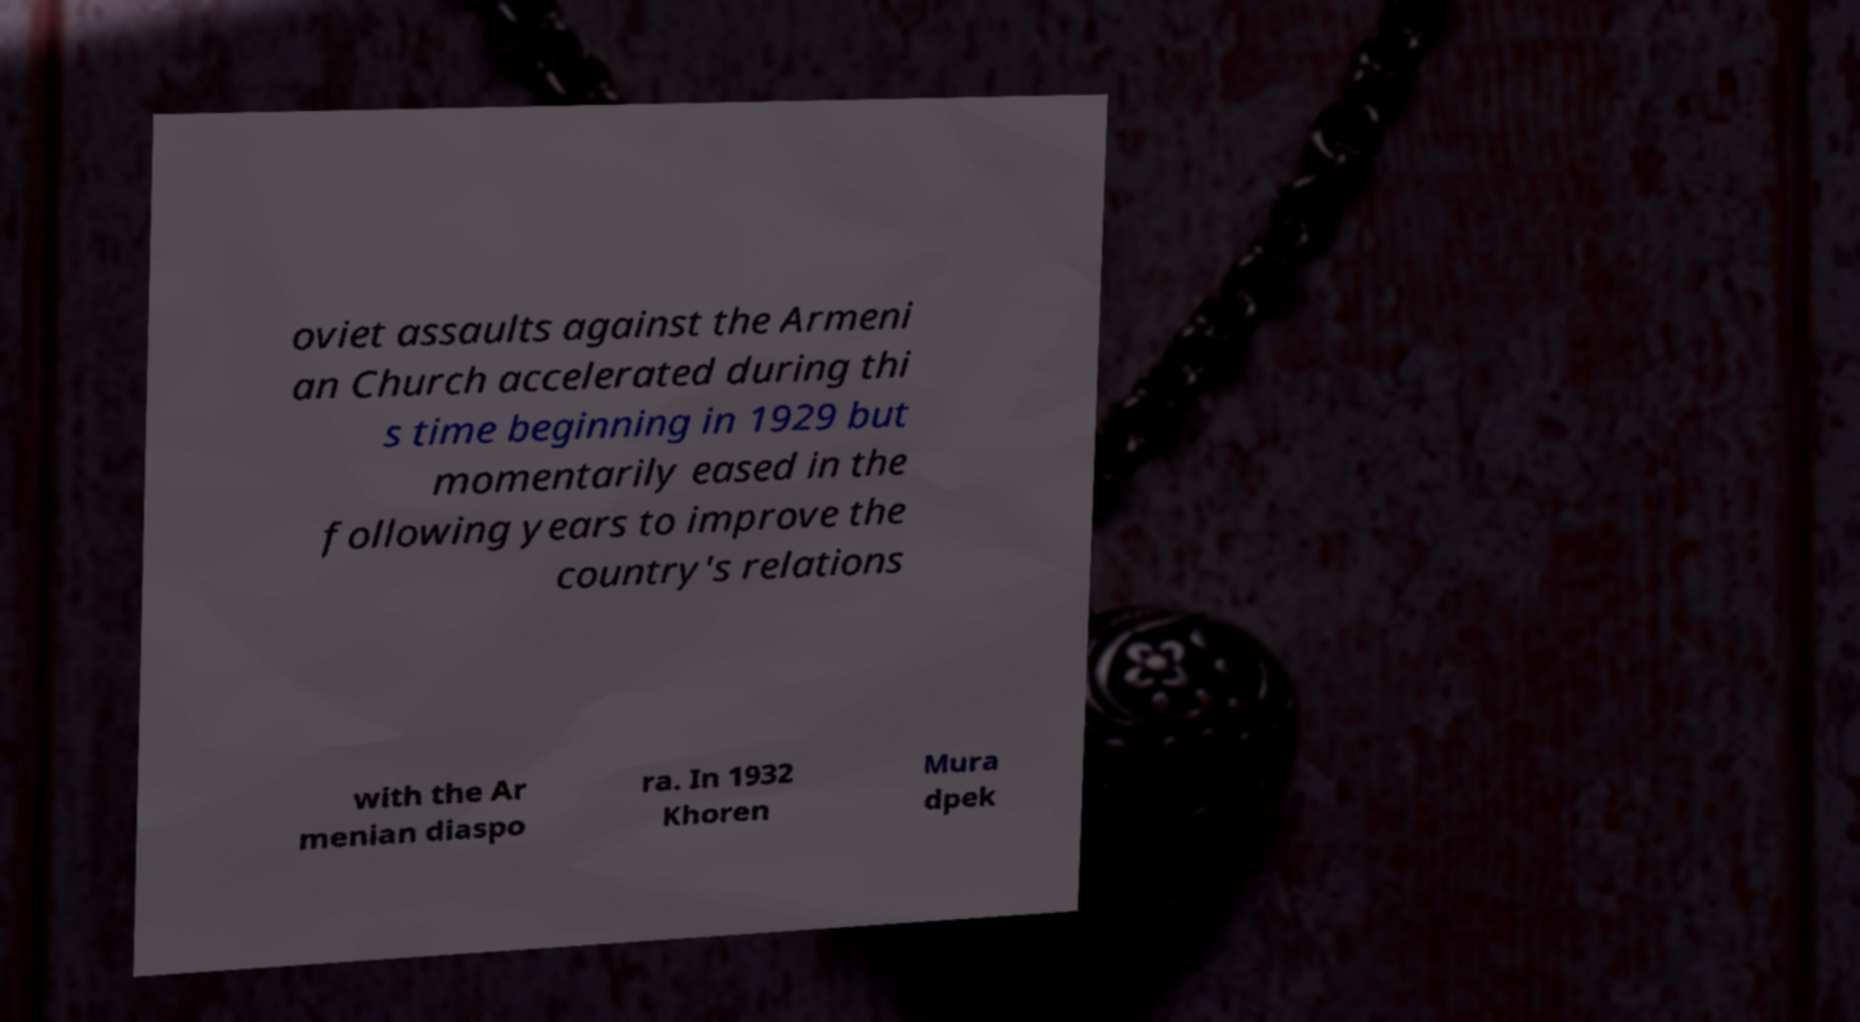Could you assist in decoding the text presented in this image and type it out clearly? oviet assaults against the Armeni an Church accelerated during thi s time beginning in 1929 but momentarily eased in the following years to improve the country's relations with the Ar menian diaspo ra. In 1932 Khoren Mura dpek 